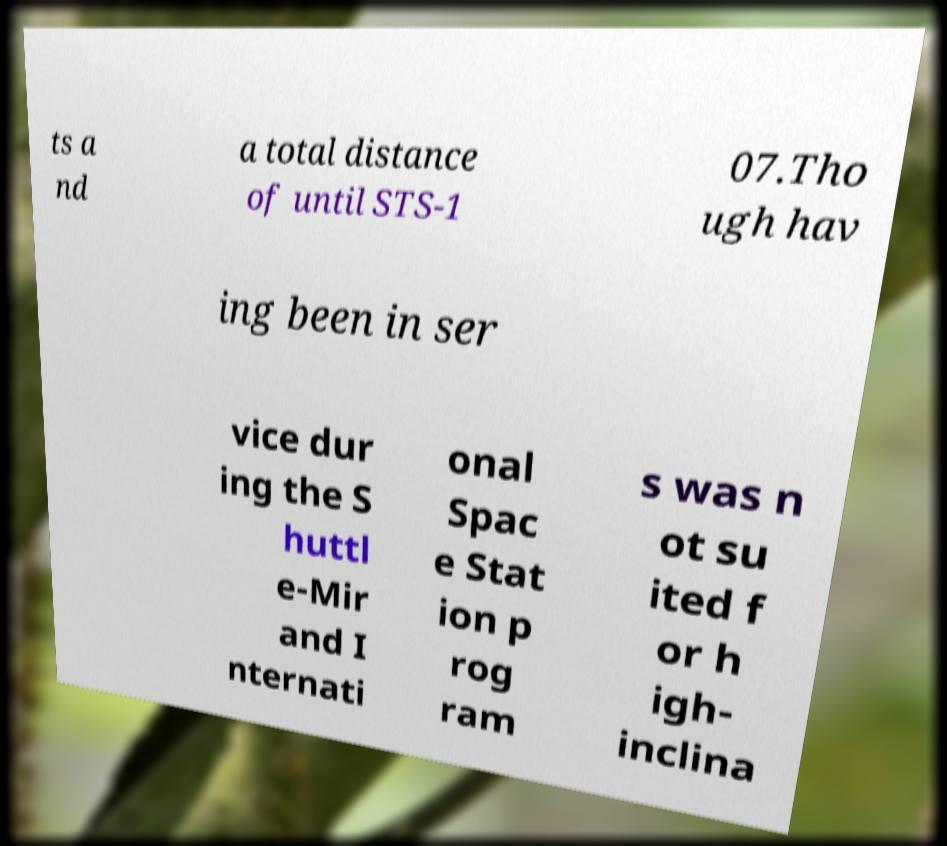What messages or text are displayed in this image? I need them in a readable, typed format. ts a nd a total distance of until STS-1 07.Tho ugh hav ing been in ser vice dur ing the S huttl e-Mir and I nternati onal Spac e Stat ion p rog ram s was n ot su ited f or h igh- inclina 